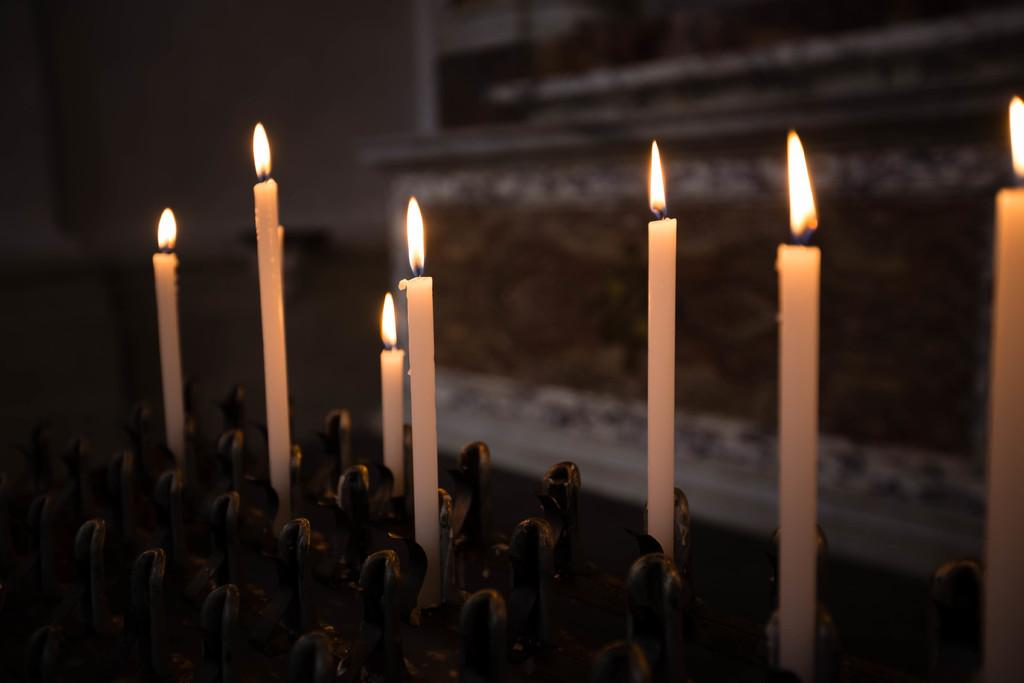What objects with flames are present in the image? There are white candles with flames in the image. Where are the candles placed? The candles are on a surface. Can you describe the background of the image? The background of the image is blurry. What can be seen in the image besides the candles? There is a wall in the image. Who is the owner of the wheel in the image? There is no wheel present in the image. 